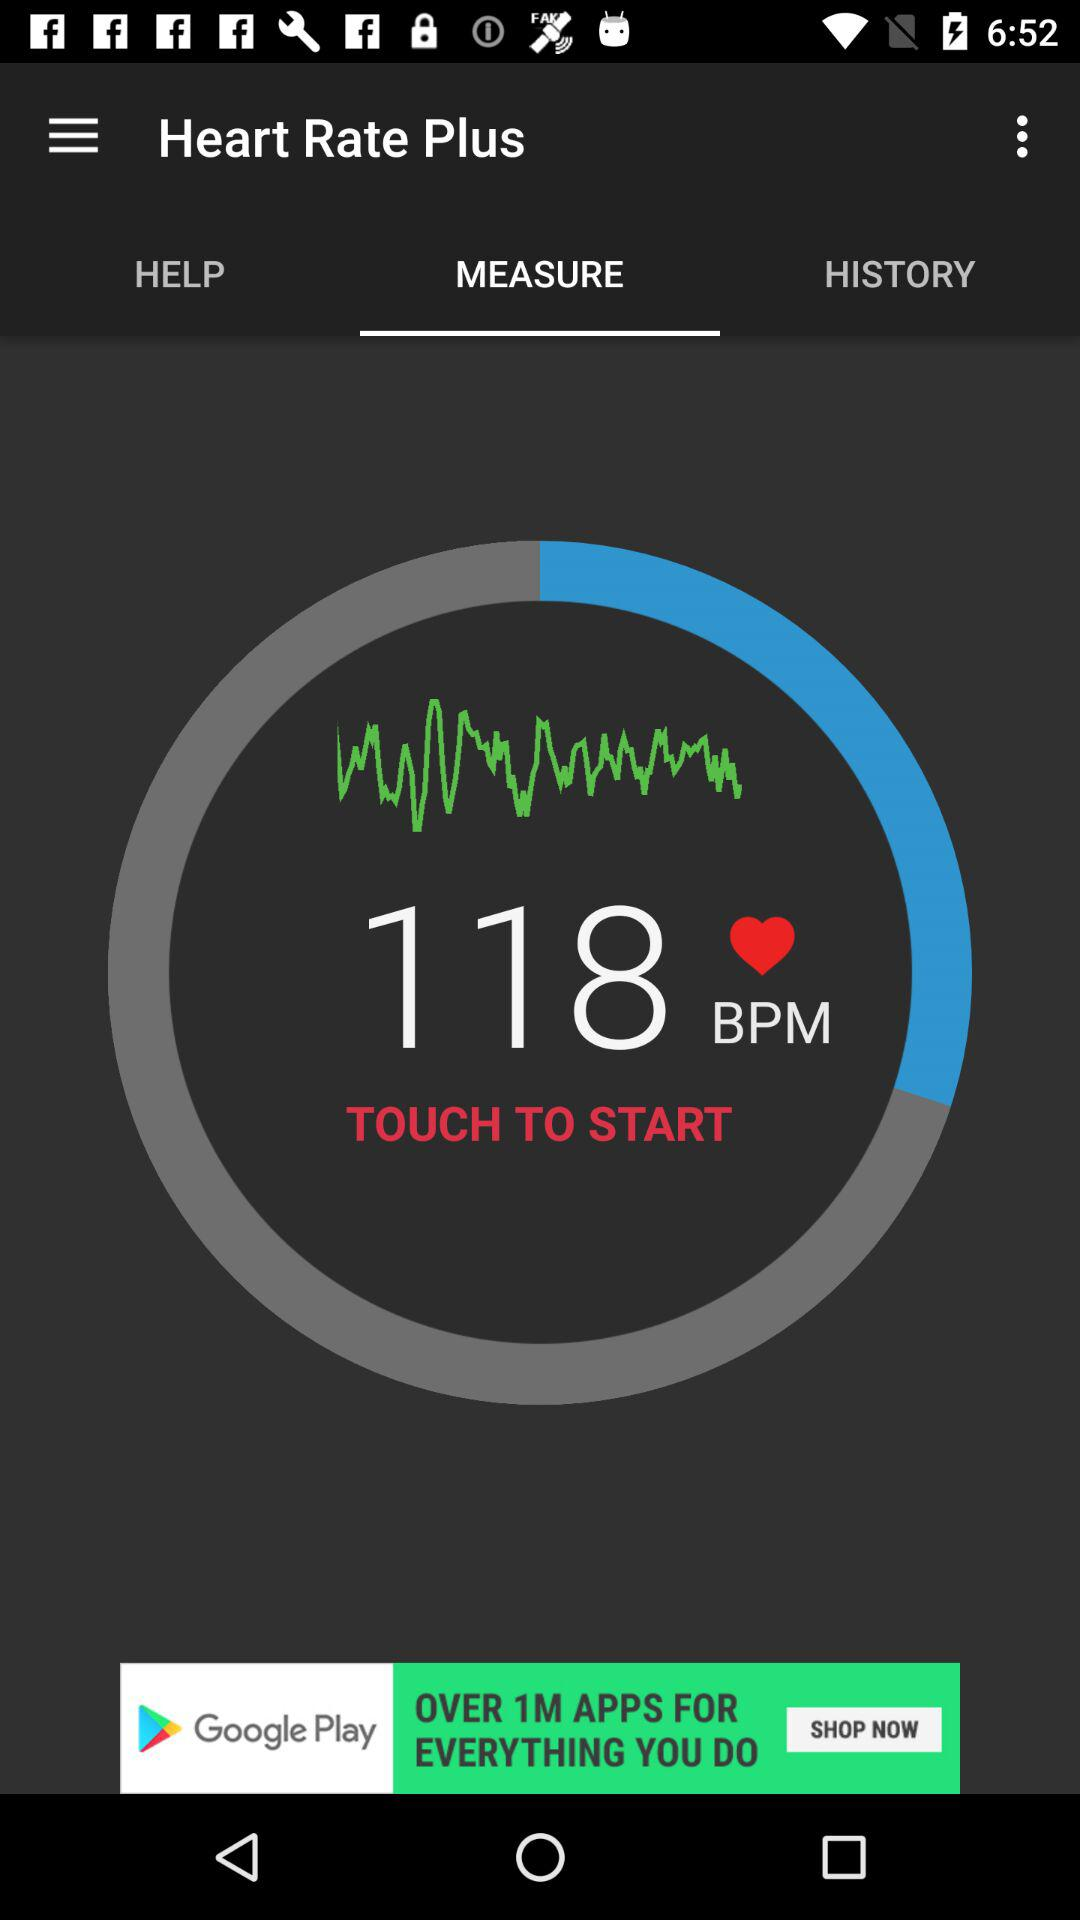What unit is used for measuring the heart rate? The unit used for measuring the heart rate is BPM. 